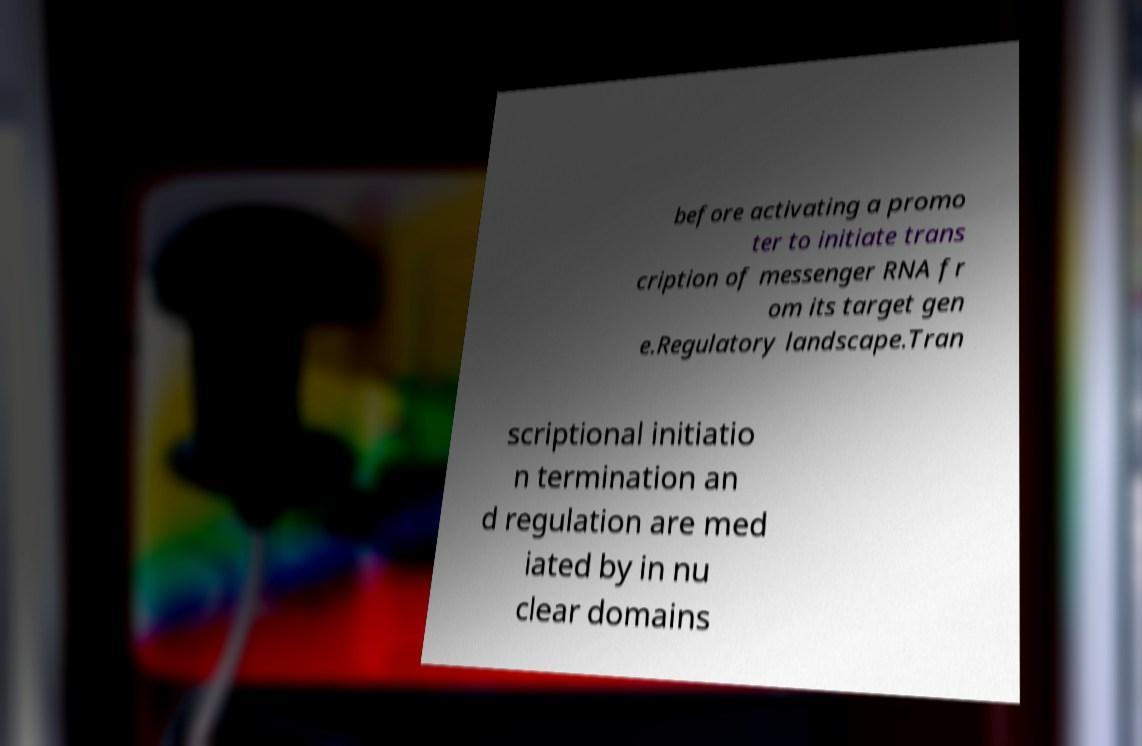There's text embedded in this image that I need extracted. Can you transcribe it verbatim? before activating a promo ter to initiate trans cription of messenger RNA fr om its target gen e.Regulatory landscape.Tran scriptional initiatio n termination an d regulation are med iated by in nu clear domains 